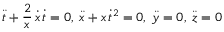<formula> <loc_0><loc_0><loc_500><loc_500>{ \ddot { t } } + { \frac { 2 } { x } } \, { \dot { x } } \, { \dot { t } } = 0 , \, { \ddot { x } } + x \, { \dot { t } } ^ { 2 } = 0 , \, { \ddot { y } } = 0 , \, { \ddot { z } } = 0</formula> 